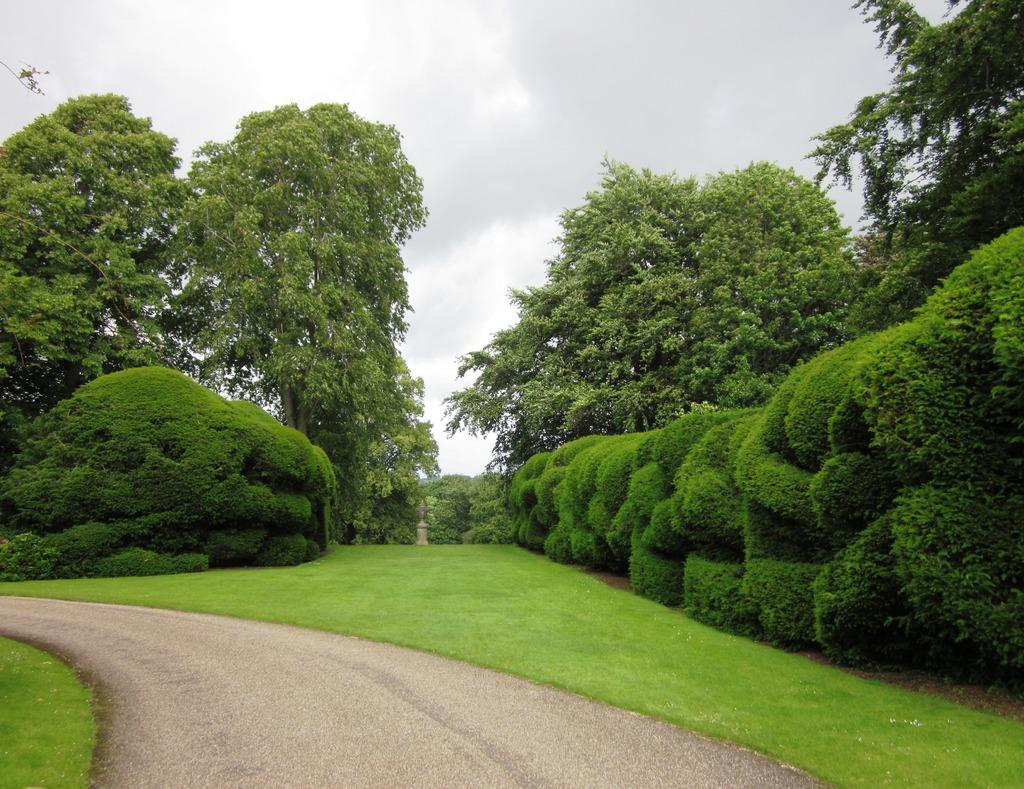What type of vegetation can be seen in the image? There are many trees, plants, and grass in the image. What is located at the bottom of the image? There is a road at the bottom of the image. What part of the natural environment is visible in the image? The sky is visible in the image, and clouds are present in the sky. What advice is the group of people giving to the trees in the image? There is no group of people present in the image, and therefore no advice-giving can be observed. 